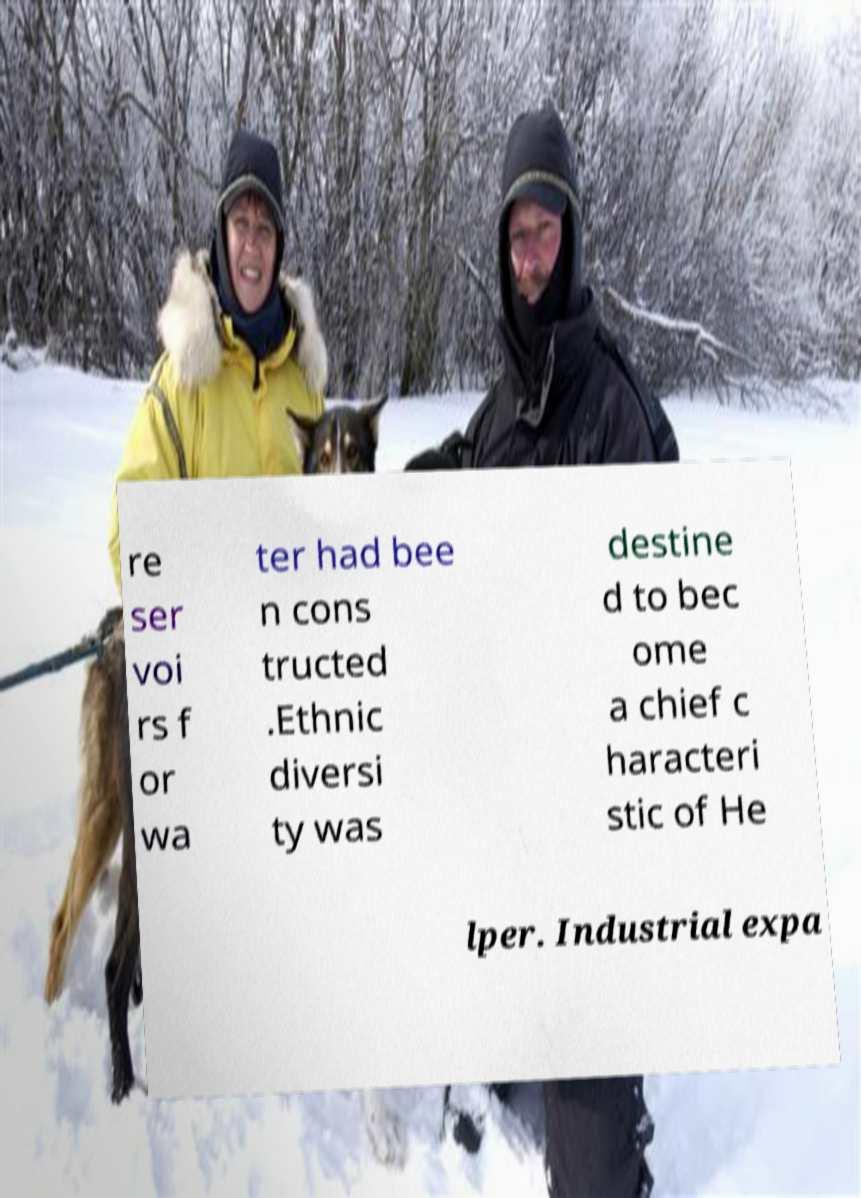Could you assist in decoding the text presented in this image and type it out clearly? re ser voi rs f or wa ter had bee n cons tructed .Ethnic diversi ty was destine d to bec ome a chief c haracteri stic of He lper. Industrial expa 